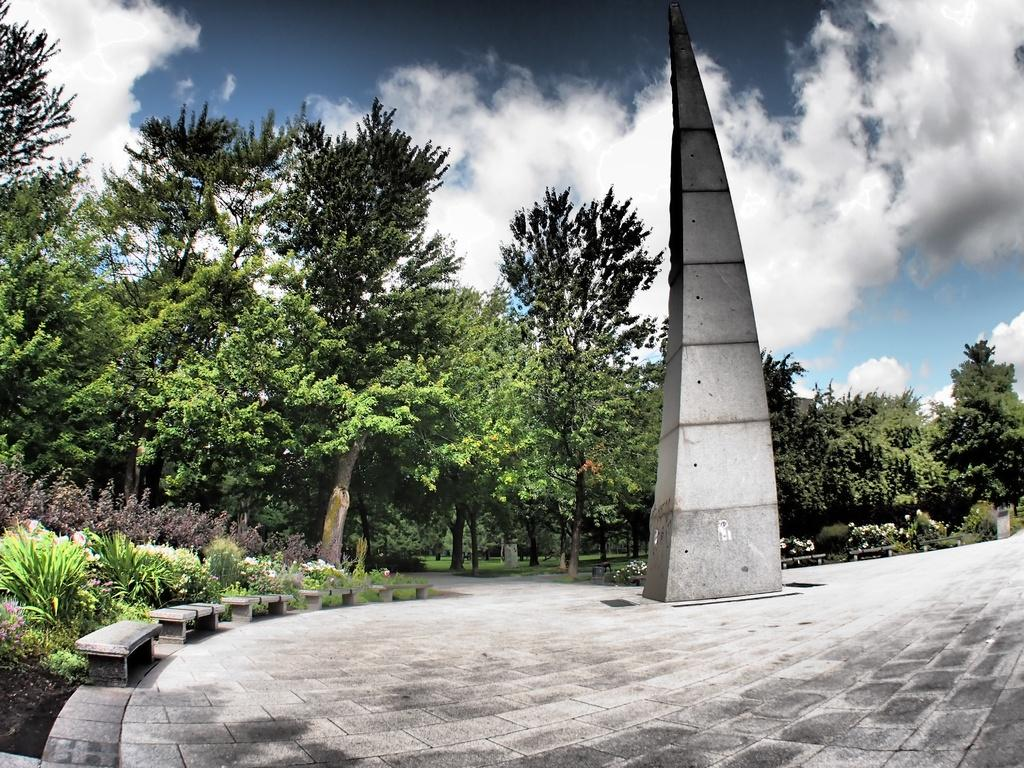What structure can be seen on the brick floor in the image? There is a pillar on a brick floor in the image. What type of seating is available on the left side of the image? There are benches on the left side of the image. What type of vegetation is present in the image? There are plants in the image. What can be seen in the background of the image? There are many trees in the background of the image. What is visible in the sky in the image? The sky is visible with clouds in the image. What type of pathway is present in the image? There is a road in the image. What type of collar can be seen on the airplane in the image? There is no airplane present in the image, so there is no collar to be seen. 